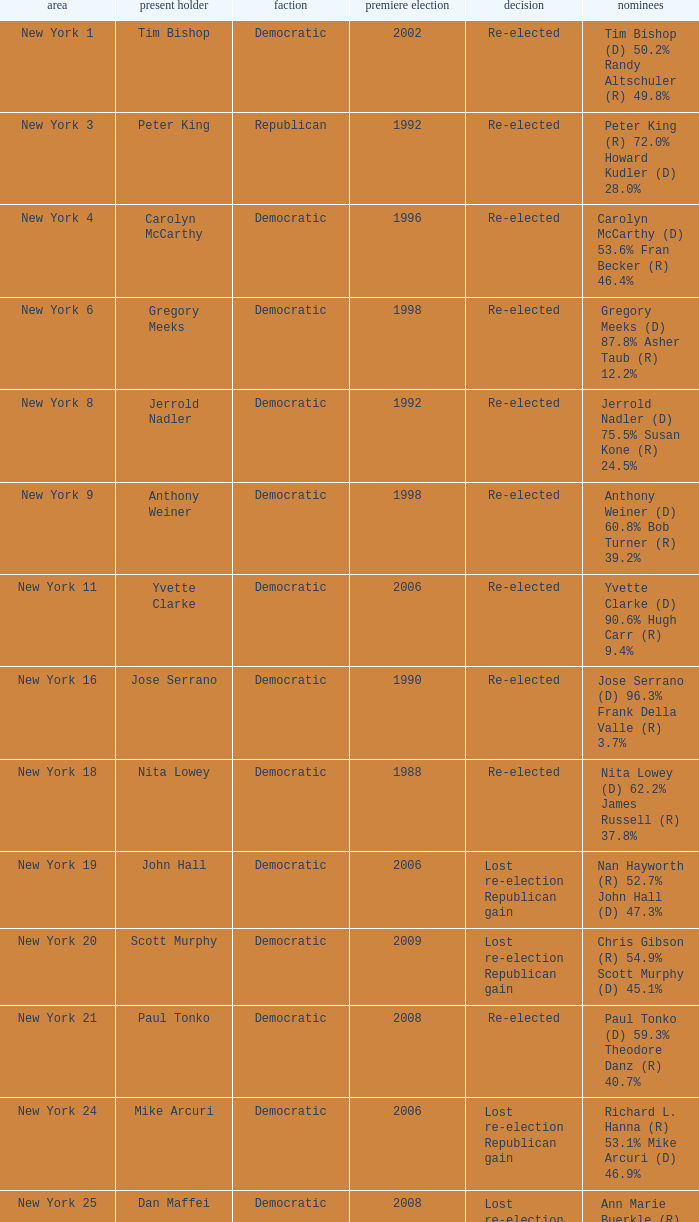Name the first elected for re-elected and brian higgins 2004.0. 